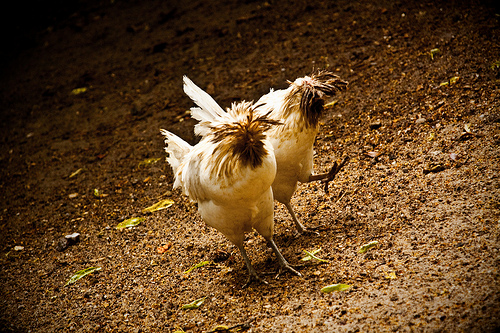<image>
Can you confirm if the chicken is under the chicken? No. The chicken is not positioned under the chicken. The vertical relationship between these objects is different. 